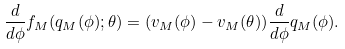<formula> <loc_0><loc_0><loc_500><loc_500>\frac { d } { d \phi } f _ { M } ( q _ { M } ( \phi ) ; \theta ) = ( v _ { M } ( \phi ) - v _ { M } ( \theta ) ) \frac { d } { d \phi } q _ { M } ( \phi ) .</formula> 